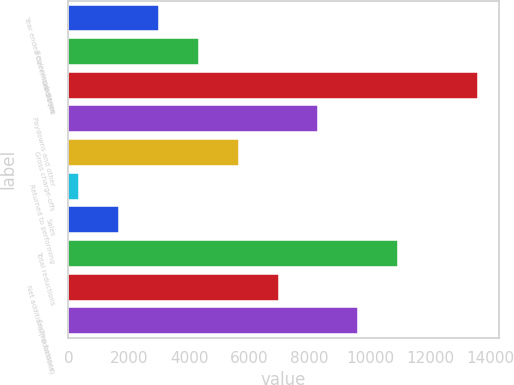<chart> <loc_0><loc_0><loc_500><loc_500><bar_chart><fcel>Year ended December 31 (in<fcel>Beginning balance<fcel>Additions<fcel>Paydowns and other<fcel>Gross charge-offs<fcel>Returned to performing<fcel>Sales<fcel>Total reductions<fcel>Net additions/(reductions)<fcel>Ending balance<nl><fcel>2991<fcel>4316<fcel>13591<fcel>8291<fcel>5641<fcel>341<fcel>1666<fcel>10941<fcel>6966<fcel>9616<nl></chart> 